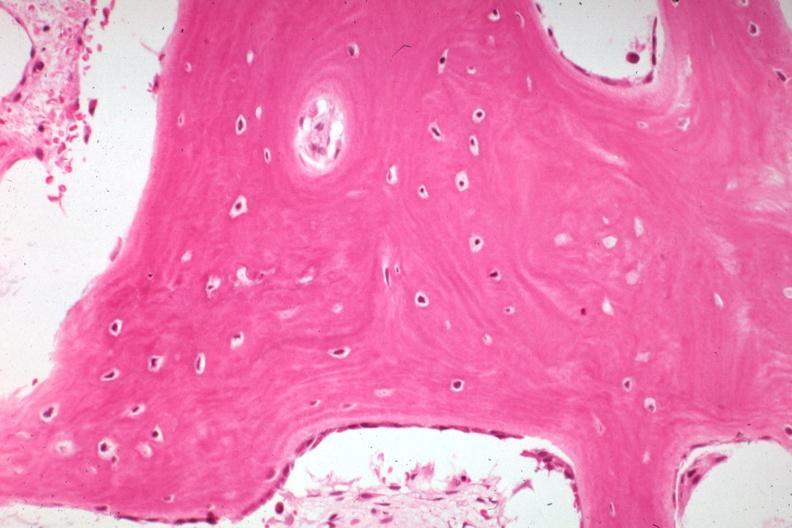does this image show high excellent example of bone with remodeling and osteoblasts that now appear inactive?
Answer the question using a single word or phrase. Yes 